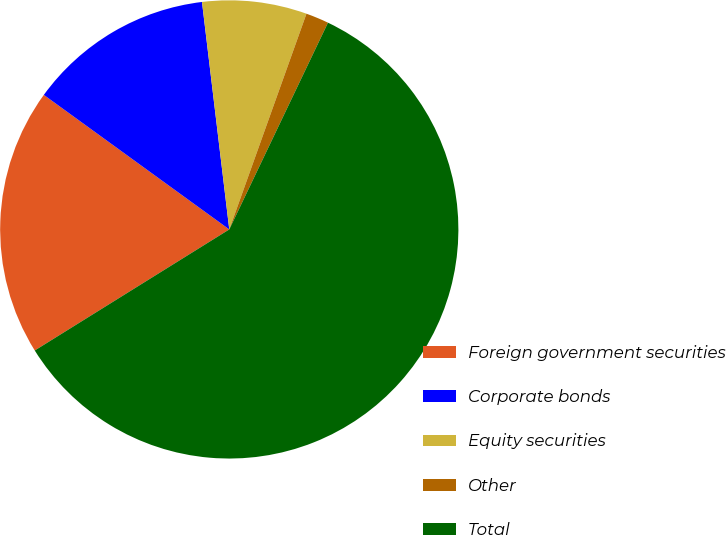<chart> <loc_0><loc_0><loc_500><loc_500><pie_chart><fcel>Foreign government securities<fcel>Corporate bonds<fcel>Equity securities<fcel>Other<fcel>Total<nl><fcel>18.85%<fcel>13.11%<fcel>7.37%<fcel>1.62%<fcel>59.05%<nl></chart> 